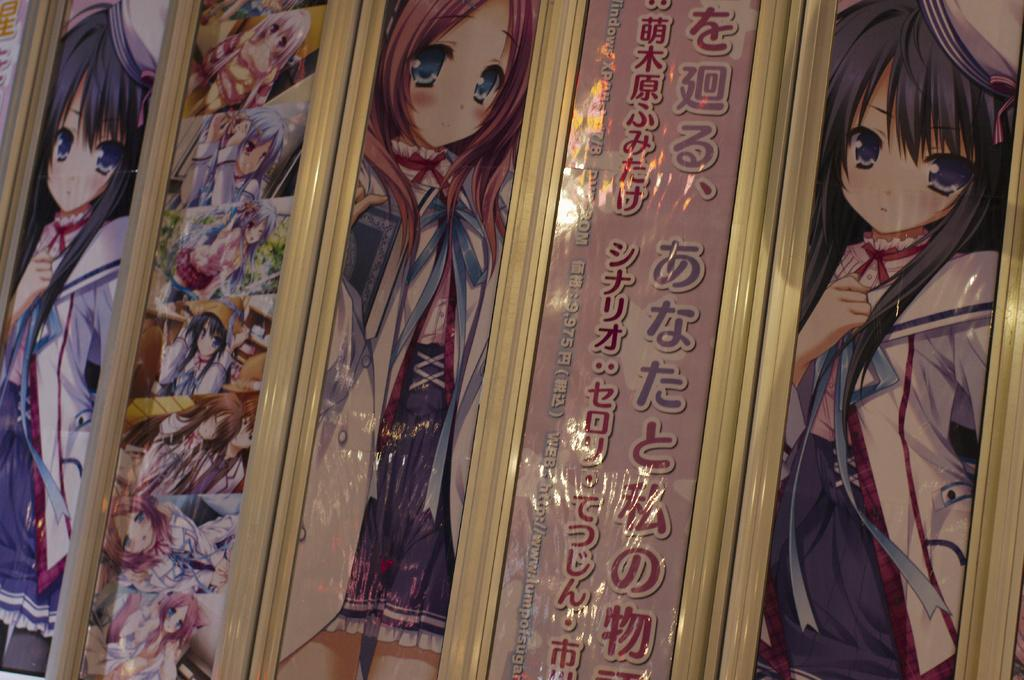What type of images are present in the picture? There are animated images of girls in the picture. How are the images displayed? The images are printed on sheets. Where are the sheets with the images attached? The sheets are attached to doors. What type of drink is being offered by the horse in the image? There is no horse present in the image, so it is not possible to answer that question. 